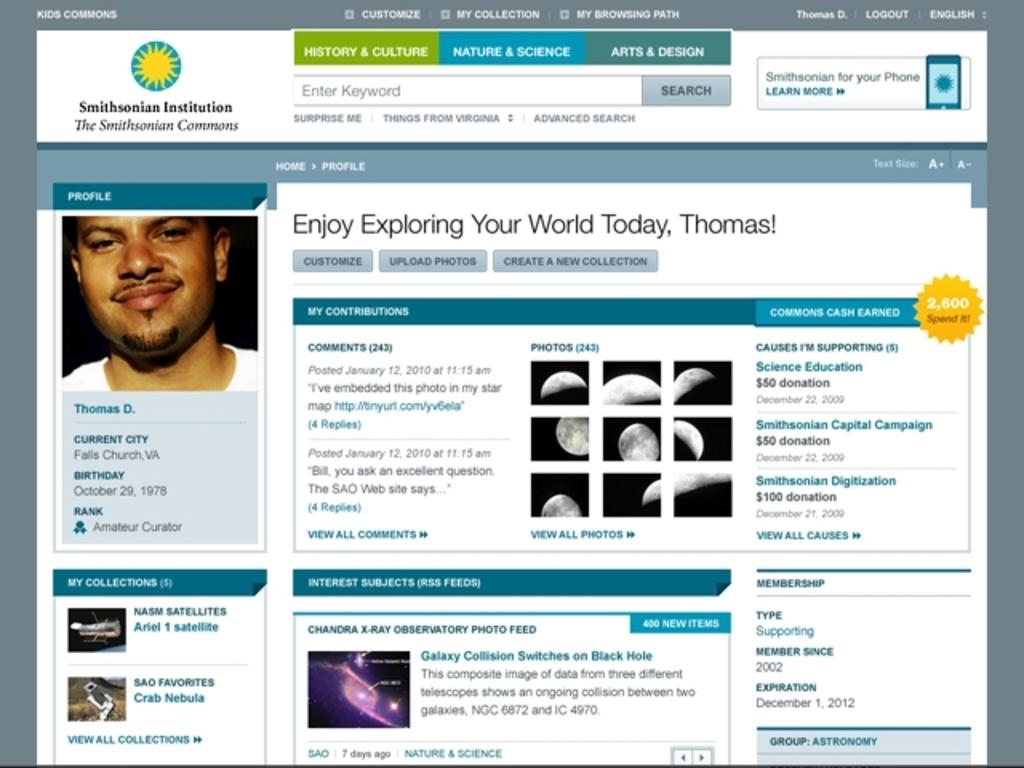What is the main subject of the web page? The main subject of the web page is a man smiling. What can be observed about the man's expression on the web page? The man is smiling on the web page. What type of content is available on the web page? There is information available on the web page. What type of reward can be seen on the web page? There is no reward visible on the web page; it only features a man smiling and information. 